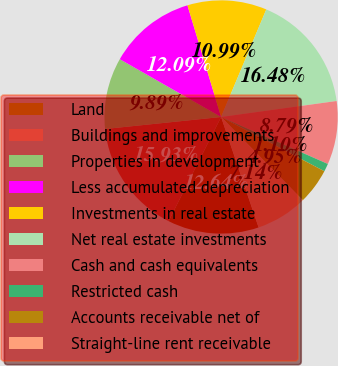Convert chart to OTSL. <chart><loc_0><loc_0><loc_500><loc_500><pie_chart><fcel>Land<fcel>Buildings and improvements<fcel>Properties in development<fcel>Less accumulated depreciation<fcel>Investments in real estate<fcel>Net real estate investments<fcel>Cash and cash equivalents<fcel>Restricted cash<fcel>Accounts receivable net of<fcel>Straight-line rent receivable<nl><fcel>12.64%<fcel>15.93%<fcel>9.89%<fcel>12.09%<fcel>10.99%<fcel>16.48%<fcel>8.79%<fcel>1.1%<fcel>4.95%<fcel>7.14%<nl></chart> 